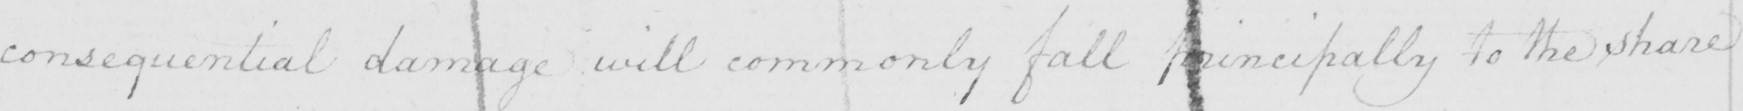What does this handwritten line say? consequential damage will commonly fall principally to the share 